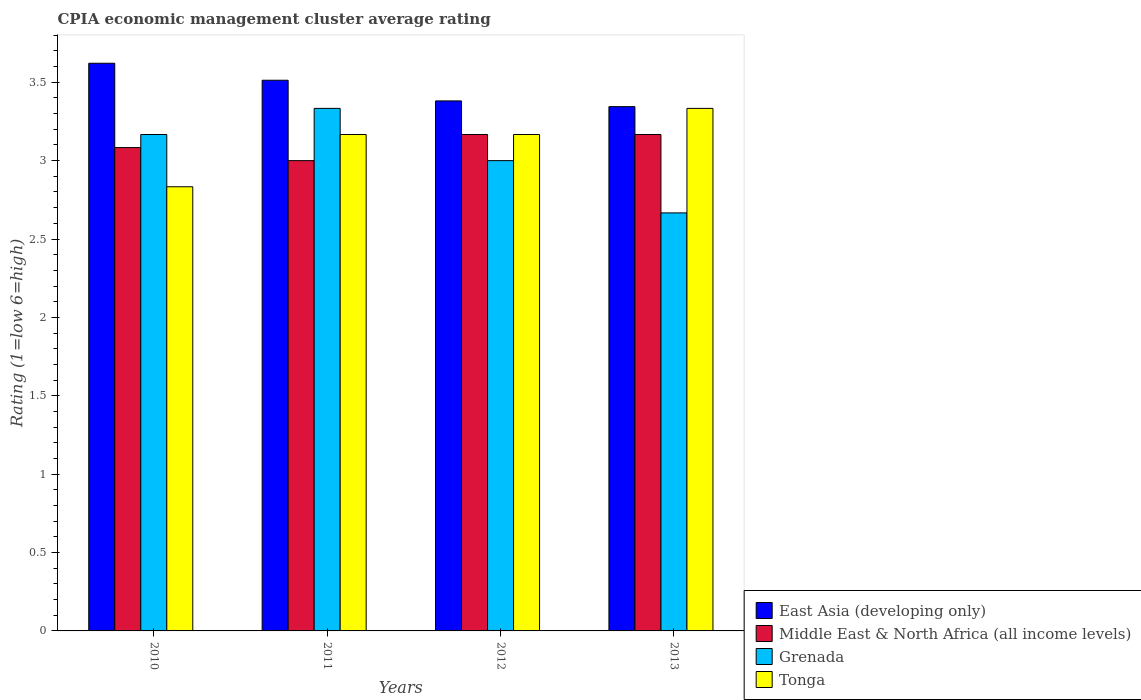How many bars are there on the 2nd tick from the right?
Ensure brevity in your answer.  4. In how many cases, is the number of bars for a given year not equal to the number of legend labels?
Provide a short and direct response. 0. What is the CPIA rating in Middle East & North Africa (all income levels) in 2012?
Provide a short and direct response. 3.17. Across all years, what is the maximum CPIA rating in Tonga?
Your response must be concise. 3.33. Across all years, what is the minimum CPIA rating in Tonga?
Your response must be concise. 2.83. In which year was the CPIA rating in Middle East & North Africa (all income levels) maximum?
Provide a succinct answer. 2012. What is the total CPIA rating in Grenada in the graph?
Offer a terse response. 12.17. What is the difference between the CPIA rating in Grenada in 2011 and that in 2013?
Your response must be concise. 0.67. What is the difference between the CPIA rating in Grenada in 2011 and the CPIA rating in Middle East & North Africa (all income levels) in 2010?
Provide a short and direct response. 0.25. What is the average CPIA rating in Grenada per year?
Your answer should be very brief. 3.04. In the year 2012, what is the difference between the CPIA rating in Middle East & North Africa (all income levels) and CPIA rating in Tonga?
Keep it short and to the point. 0. In how many years, is the CPIA rating in East Asia (developing only) greater than 0.1?
Ensure brevity in your answer.  4. What is the ratio of the CPIA rating in Tonga in 2010 to that in 2012?
Provide a short and direct response. 0.89. What is the difference between the highest and the second highest CPIA rating in East Asia (developing only)?
Offer a very short reply. 0.11. What is the difference between the highest and the lowest CPIA rating in Grenada?
Ensure brevity in your answer.  0.67. What does the 2nd bar from the left in 2010 represents?
Provide a succinct answer. Middle East & North Africa (all income levels). What does the 3rd bar from the right in 2012 represents?
Provide a succinct answer. Middle East & North Africa (all income levels). Is it the case that in every year, the sum of the CPIA rating in Middle East & North Africa (all income levels) and CPIA rating in East Asia (developing only) is greater than the CPIA rating in Tonga?
Offer a terse response. Yes. How many bars are there?
Your answer should be compact. 16. What is the difference between two consecutive major ticks on the Y-axis?
Keep it short and to the point. 0.5. Are the values on the major ticks of Y-axis written in scientific E-notation?
Ensure brevity in your answer.  No. Does the graph contain any zero values?
Offer a terse response. No. Does the graph contain grids?
Your answer should be very brief. No. How many legend labels are there?
Your answer should be compact. 4. What is the title of the graph?
Your response must be concise. CPIA economic management cluster average rating. What is the label or title of the X-axis?
Keep it short and to the point. Years. What is the Rating (1=low 6=high) of East Asia (developing only) in 2010?
Keep it short and to the point. 3.62. What is the Rating (1=low 6=high) in Middle East & North Africa (all income levels) in 2010?
Provide a short and direct response. 3.08. What is the Rating (1=low 6=high) in Grenada in 2010?
Give a very brief answer. 3.17. What is the Rating (1=low 6=high) in Tonga in 2010?
Provide a succinct answer. 2.83. What is the Rating (1=low 6=high) of East Asia (developing only) in 2011?
Give a very brief answer. 3.51. What is the Rating (1=low 6=high) of Middle East & North Africa (all income levels) in 2011?
Your response must be concise. 3. What is the Rating (1=low 6=high) of Grenada in 2011?
Provide a succinct answer. 3.33. What is the Rating (1=low 6=high) in Tonga in 2011?
Offer a very short reply. 3.17. What is the Rating (1=low 6=high) of East Asia (developing only) in 2012?
Your response must be concise. 3.38. What is the Rating (1=low 6=high) of Middle East & North Africa (all income levels) in 2012?
Keep it short and to the point. 3.17. What is the Rating (1=low 6=high) of Grenada in 2012?
Offer a very short reply. 3. What is the Rating (1=low 6=high) in Tonga in 2012?
Offer a terse response. 3.17. What is the Rating (1=low 6=high) in East Asia (developing only) in 2013?
Ensure brevity in your answer.  3.34. What is the Rating (1=low 6=high) in Middle East & North Africa (all income levels) in 2013?
Offer a very short reply. 3.17. What is the Rating (1=low 6=high) of Grenada in 2013?
Provide a short and direct response. 2.67. What is the Rating (1=low 6=high) in Tonga in 2013?
Keep it short and to the point. 3.33. Across all years, what is the maximum Rating (1=low 6=high) of East Asia (developing only)?
Your answer should be compact. 3.62. Across all years, what is the maximum Rating (1=low 6=high) in Middle East & North Africa (all income levels)?
Provide a short and direct response. 3.17. Across all years, what is the maximum Rating (1=low 6=high) of Grenada?
Your response must be concise. 3.33. Across all years, what is the maximum Rating (1=low 6=high) of Tonga?
Provide a succinct answer. 3.33. Across all years, what is the minimum Rating (1=low 6=high) in East Asia (developing only)?
Provide a short and direct response. 3.34. Across all years, what is the minimum Rating (1=low 6=high) of Grenada?
Offer a very short reply. 2.67. Across all years, what is the minimum Rating (1=low 6=high) of Tonga?
Offer a terse response. 2.83. What is the total Rating (1=low 6=high) of East Asia (developing only) in the graph?
Offer a terse response. 13.86. What is the total Rating (1=low 6=high) in Middle East & North Africa (all income levels) in the graph?
Your answer should be compact. 12.42. What is the total Rating (1=low 6=high) of Grenada in the graph?
Your answer should be very brief. 12.17. What is the difference between the Rating (1=low 6=high) of East Asia (developing only) in 2010 and that in 2011?
Your response must be concise. 0.11. What is the difference between the Rating (1=low 6=high) of Middle East & North Africa (all income levels) in 2010 and that in 2011?
Your answer should be very brief. 0.08. What is the difference between the Rating (1=low 6=high) of Grenada in 2010 and that in 2011?
Provide a short and direct response. -0.17. What is the difference between the Rating (1=low 6=high) in Tonga in 2010 and that in 2011?
Make the answer very short. -0.33. What is the difference between the Rating (1=low 6=high) in East Asia (developing only) in 2010 and that in 2012?
Your response must be concise. 0.24. What is the difference between the Rating (1=low 6=high) in Middle East & North Africa (all income levels) in 2010 and that in 2012?
Your answer should be very brief. -0.08. What is the difference between the Rating (1=low 6=high) in Grenada in 2010 and that in 2012?
Your answer should be very brief. 0.17. What is the difference between the Rating (1=low 6=high) of Tonga in 2010 and that in 2012?
Provide a succinct answer. -0.33. What is the difference between the Rating (1=low 6=high) of East Asia (developing only) in 2010 and that in 2013?
Ensure brevity in your answer.  0.28. What is the difference between the Rating (1=low 6=high) in Middle East & North Africa (all income levels) in 2010 and that in 2013?
Offer a very short reply. -0.08. What is the difference between the Rating (1=low 6=high) of Grenada in 2010 and that in 2013?
Provide a succinct answer. 0.5. What is the difference between the Rating (1=low 6=high) of Tonga in 2010 and that in 2013?
Your answer should be compact. -0.5. What is the difference between the Rating (1=low 6=high) of East Asia (developing only) in 2011 and that in 2012?
Your response must be concise. 0.13. What is the difference between the Rating (1=low 6=high) in Grenada in 2011 and that in 2012?
Your answer should be compact. 0.33. What is the difference between the Rating (1=low 6=high) of Tonga in 2011 and that in 2012?
Offer a very short reply. 0. What is the difference between the Rating (1=low 6=high) of East Asia (developing only) in 2011 and that in 2013?
Ensure brevity in your answer.  0.17. What is the difference between the Rating (1=low 6=high) of Grenada in 2011 and that in 2013?
Make the answer very short. 0.67. What is the difference between the Rating (1=low 6=high) of East Asia (developing only) in 2012 and that in 2013?
Make the answer very short. 0.04. What is the difference between the Rating (1=low 6=high) of Tonga in 2012 and that in 2013?
Ensure brevity in your answer.  -0.17. What is the difference between the Rating (1=low 6=high) of East Asia (developing only) in 2010 and the Rating (1=low 6=high) of Middle East & North Africa (all income levels) in 2011?
Your answer should be very brief. 0.62. What is the difference between the Rating (1=low 6=high) in East Asia (developing only) in 2010 and the Rating (1=low 6=high) in Grenada in 2011?
Ensure brevity in your answer.  0.29. What is the difference between the Rating (1=low 6=high) in East Asia (developing only) in 2010 and the Rating (1=low 6=high) in Tonga in 2011?
Ensure brevity in your answer.  0.45. What is the difference between the Rating (1=low 6=high) of Middle East & North Africa (all income levels) in 2010 and the Rating (1=low 6=high) of Tonga in 2011?
Ensure brevity in your answer.  -0.08. What is the difference between the Rating (1=low 6=high) in Grenada in 2010 and the Rating (1=low 6=high) in Tonga in 2011?
Ensure brevity in your answer.  0. What is the difference between the Rating (1=low 6=high) in East Asia (developing only) in 2010 and the Rating (1=low 6=high) in Middle East & North Africa (all income levels) in 2012?
Keep it short and to the point. 0.45. What is the difference between the Rating (1=low 6=high) of East Asia (developing only) in 2010 and the Rating (1=low 6=high) of Grenada in 2012?
Ensure brevity in your answer.  0.62. What is the difference between the Rating (1=low 6=high) in East Asia (developing only) in 2010 and the Rating (1=low 6=high) in Tonga in 2012?
Provide a succinct answer. 0.45. What is the difference between the Rating (1=low 6=high) of Middle East & North Africa (all income levels) in 2010 and the Rating (1=low 6=high) of Grenada in 2012?
Keep it short and to the point. 0.08. What is the difference between the Rating (1=low 6=high) of Middle East & North Africa (all income levels) in 2010 and the Rating (1=low 6=high) of Tonga in 2012?
Your response must be concise. -0.08. What is the difference between the Rating (1=low 6=high) of East Asia (developing only) in 2010 and the Rating (1=low 6=high) of Middle East & North Africa (all income levels) in 2013?
Your answer should be compact. 0.45. What is the difference between the Rating (1=low 6=high) of East Asia (developing only) in 2010 and the Rating (1=low 6=high) of Grenada in 2013?
Offer a terse response. 0.95. What is the difference between the Rating (1=low 6=high) of East Asia (developing only) in 2010 and the Rating (1=low 6=high) of Tonga in 2013?
Make the answer very short. 0.29. What is the difference between the Rating (1=low 6=high) in Middle East & North Africa (all income levels) in 2010 and the Rating (1=low 6=high) in Grenada in 2013?
Provide a short and direct response. 0.42. What is the difference between the Rating (1=low 6=high) of Grenada in 2010 and the Rating (1=low 6=high) of Tonga in 2013?
Provide a short and direct response. -0.17. What is the difference between the Rating (1=low 6=high) of East Asia (developing only) in 2011 and the Rating (1=low 6=high) of Middle East & North Africa (all income levels) in 2012?
Provide a short and direct response. 0.35. What is the difference between the Rating (1=low 6=high) in East Asia (developing only) in 2011 and the Rating (1=low 6=high) in Grenada in 2012?
Offer a very short reply. 0.51. What is the difference between the Rating (1=low 6=high) of East Asia (developing only) in 2011 and the Rating (1=low 6=high) of Tonga in 2012?
Your answer should be compact. 0.35. What is the difference between the Rating (1=low 6=high) of Middle East & North Africa (all income levels) in 2011 and the Rating (1=low 6=high) of Grenada in 2012?
Make the answer very short. 0. What is the difference between the Rating (1=low 6=high) of Middle East & North Africa (all income levels) in 2011 and the Rating (1=low 6=high) of Tonga in 2012?
Offer a very short reply. -0.17. What is the difference between the Rating (1=low 6=high) in East Asia (developing only) in 2011 and the Rating (1=low 6=high) in Middle East & North Africa (all income levels) in 2013?
Offer a very short reply. 0.35. What is the difference between the Rating (1=low 6=high) in East Asia (developing only) in 2011 and the Rating (1=low 6=high) in Grenada in 2013?
Provide a succinct answer. 0.85. What is the difference between the Rating (1=low 6=high) in East Asia (developing only) in 2011 and the Rating (1=low 6=high) in Tonga in 2013?
Offer a very short reply. 0.18. What is the difference between the Rating (1=low 6=high) of East Asia (developing only) in 2012 and the Rating (1=low 6=high) of Middle East & North Africa (all income levels) in 2013?
Offer a very short reply. 0.21. What is the difference between the Rating (1=low 6=high) in East Asia (developing only) in 2012 and the Rating (1=low 6=high) in Tonga in 2013?
Offer a terse response. 0.05. What is the difference between the Rating (1=low 6=high) in Grenada in 2012 and the Rating (1=low 6=high) in Tonga in 2013?
Provide a succinct answer. -0.33. What is the average Rating (1=low 6=high) of East Asia (developing only) per year?
Keep it short and to the point. 3.46. What is the average Rating (1=low 6=high) in Middle East & North Africa (all income levels) per year?
Your response must be concise. 3.1. What is the average Rating (1=low 6=high) in Grenada per year?
Give a very brief answer. 3.04. What is the average Rating (1=low 6=high) of Tonga per year?
Ensure brevity in your answer.  3.12. In the year 2010, what is the difference between the Rating (1=low 6=high) in East Asia (developing only) and Rating (1=low 6=high) in Middle East & North Africa (all income levels)?
Ensure brevity in your answer.  0.54. In the year 2010, what is the difference between the Rating (1=low 6=high) in East Asia (developing only) and Rating (1=low 6=high) in Grenada?
Ensure brevity in your answer.  0.45. In the year 2010, what is the difference between the Rating (1=low 6=high) in East Asia (developing only) and Rating (1=low 6=high) in Tonga?
Offer a very short reply. 0.79. In the year 2010, what is the difference between the Rating (1=low 6=high) in Middle East & North Africa (all income levels) and Rating (1=low 6=high) in Grenada?
Make the answer very short. -0.08. In the year 2011, what is the difference between the Rating (1=low 6=high) of East Asia (developing only) and Rating (1=low 6=high) of Middle East & North Africa (all income levels)?
Offer a very short reply. 0.51. In the year 2011, what is the difference between the Rating (1=low 6=high) of East Asia (developing only) and Rating (1=low 6=high) of Grenada?
Provide a short and direct response. 0.18. In the year 2011, what is the difference between the Rating (1=low 6=high) of East Asia (developing only) and Rating (1=low 6=high) of Tonga?
Provide a succinct answer. 0.35. In the year 2011, what is the difference between the Rating (1=low 6=high) in Middle East & North Africa (all income levels) and Rating (1=low 6=high) in Tonga?
Your answer should be compact. -0.17. In the year 2011, what is the difference between the Rating (1=low 6=high) in Grenada and Rating (1=low 6=high) in Tonga?
Your answer should be compact. 0.17. In the year 2012, what is the difference between the Rating (1=low 6=high) in East Asia (developing only) and Rating (1=low 6=high) in Middle East & North Africa (all income levels)?
Keep it short and to the point. 0.21. In the year 2012, what is the difference between the Rating (1=low 6=high) of East Asia (developing only) and Rating (1=low 6=high) of Grenada?
Make the answer very short. 0.38. In the year 2012, what is the difference between the Rating (1=low 6=high) in East Asia (developing only) and Rating (1=low 6=high) in Tonga?
Offer a very short reply. 0.21. In the year 2013, what is the difference between the Rating (1=low 6=high) of East Asia (developing only) and Rating (1=low 6=high) of Middle East & North Africa (all income levels)?
Your response must be concise. 0.18. In the year 2013, what is the difference between the Rating (1=low 6=high) in East Asia (developing only) and Rating (1=low 6=high) in Grenada?
Your answer should be compact. 0.68. In the year 2013, what is the difference between the Rating (1=low 6=high) of East Asia (developing only) and Rating (1=low 6=high) of Tonga?
Provide a succinct answer. 0.01. In the year 2013, what is the difference between the Rating (1=low 6=high) in Middle East & North Africa (all income levels) and Rating (1=low 6=high) in Grenada?
Your answer should be compact. 0.5. What is the ratio of the Rating (1=low 6=high) of East Asia (developing only) in 2010 to that in 2011?
Make the answer very short. 1.03. What is the ratio of the Rating (1=low 6=high) of Middle East & North Africa (all income levels) in 2010 to that in 2011?
Provide a succinct answer. 1.03. What is the ratio of the Rating (1=low 6=high) of Grenada in 2010 to that in 2011?
Offer a very short reply. 0.95. What is the ratio of the Rating (1=low 6=high) in Tonga in 2010 to that in 2011?
Give a very brief answer. 0.89. What is the ratio of the Rating (1=low 6=high) of East Asia (developing only) in 2010 to that in 2012?
Make the answer very short. 1.07. What is the ratio of the Rating (1=low 6=high) of Middle East & North Africa (all income levels) in 2010 to that in 2012?
Make the answer very short. 0.97. What is the ratio of the Rating (1=low 6=high) in Grenada in 2010 to that in 2012?
Keep it short and to the point. 1.06. What is the ratio of the Rating (1=low 6=high) of Tonga in 2010 to that in 2012?
Provide a succinct answer. 0.89. What is the ratio of the Rating (1=low 6=high) in East Asia (developing only) in 2010 to that in 2013?
Offer a very short reply. 1.08. What is the ratio of the Rating (1=low 6=high) in Middle East & North Africa (all income levels) in 2010 to that in 2013?
Provide a short and direct response. 0.97. What is the ratio of the Rating (1=low 6=high) of Grenada in 2010 to that in 2013?
Give a very brief answer. 1.19. What is the ratio of the Rating (1=low 6=high) in East Asia (developing only) in 2011 to that in 2012?
Offer a very short reply. 1.04. What is the ratio of the Rating (1=low 6=high) of Tonga in 2011 to that in 2012?
Keep it short and to the point. 1. What is the ratio of the Rating (1=low 6=high) of East Asia (developing only) in 2011 to that in 2013?
Give a very brief answer. 1.05. What is the ratio of the Rating (1=low 6=high) in Middle East & North Africa (all income levels) in 2011 to that in 2013?
Offer a very short reply. 0.95. What is the ratio of the Rating (1=low 6=high) of Grenada in 2011 to that in 2013?
Offer a terse response. 1.25. What is the ratio of the Rating (1=low 6=high) of East Asia (developing only) in 2012 to that in 2013?
Provide a succinct answer. 1.01. What is the difference between the highest and the second highest Rating (1=low 6=high) of East Asia (developing only)?
Make the answer very short. 0.11. What is the difference between the highest and the second highest Rating (1=low 6=high) in Middle East & North Africa (all income levels)?
Your answer should be very brief. 0. What is the difference between the highest and the second highest Rating (1=low 6=high) of Grenada?
Make the answer very short. 0.17. What is the difference between the highest and the lowest Rating (1=low 6=high) of East Asia (developing only)?
Provide a short and direct response. 0.28. What is the difference between the highest and the lowest Rating (1=low 6=high) of Middle East & North Africa (all income levels)?
Make the answer very short. 0.17. What is the difference between the highest and the lowest Rating (1=low 6=high) in Grenada?
Provide a short and direct response. 0.67. What is the difference between the highest and the lowest Rating (1=low 6=high) of Tonga?
Provide a short and direct response. 0.5. 